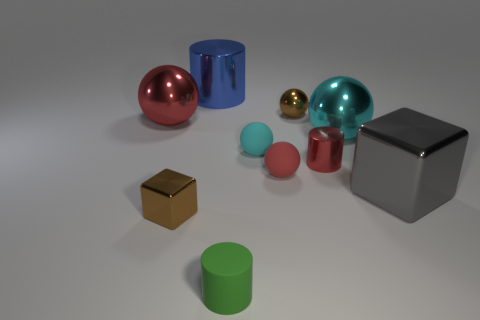Subtract 2 spheres. How many spheres are left? 3 Subtract all red balls. How many balls are left? 3 Subtract all tiny metallic balls. How many balls are left? 4 Subtract all blue spheres. Subtract all cyan cylinders. How many spheres are left? 5 Subtract all cylinders. How many objects are left? 7 Add 7 small yellow metallic cylinders. How many small yellow metallic cylinders exist? 7 Subtract 0 green balls. How many objects are left? 10 Subtract all small brown objects. Subtract all big cyan spheres. How many objects are left? 7 Add 1 small red cylinders. How many small red cylinders are left? 2 